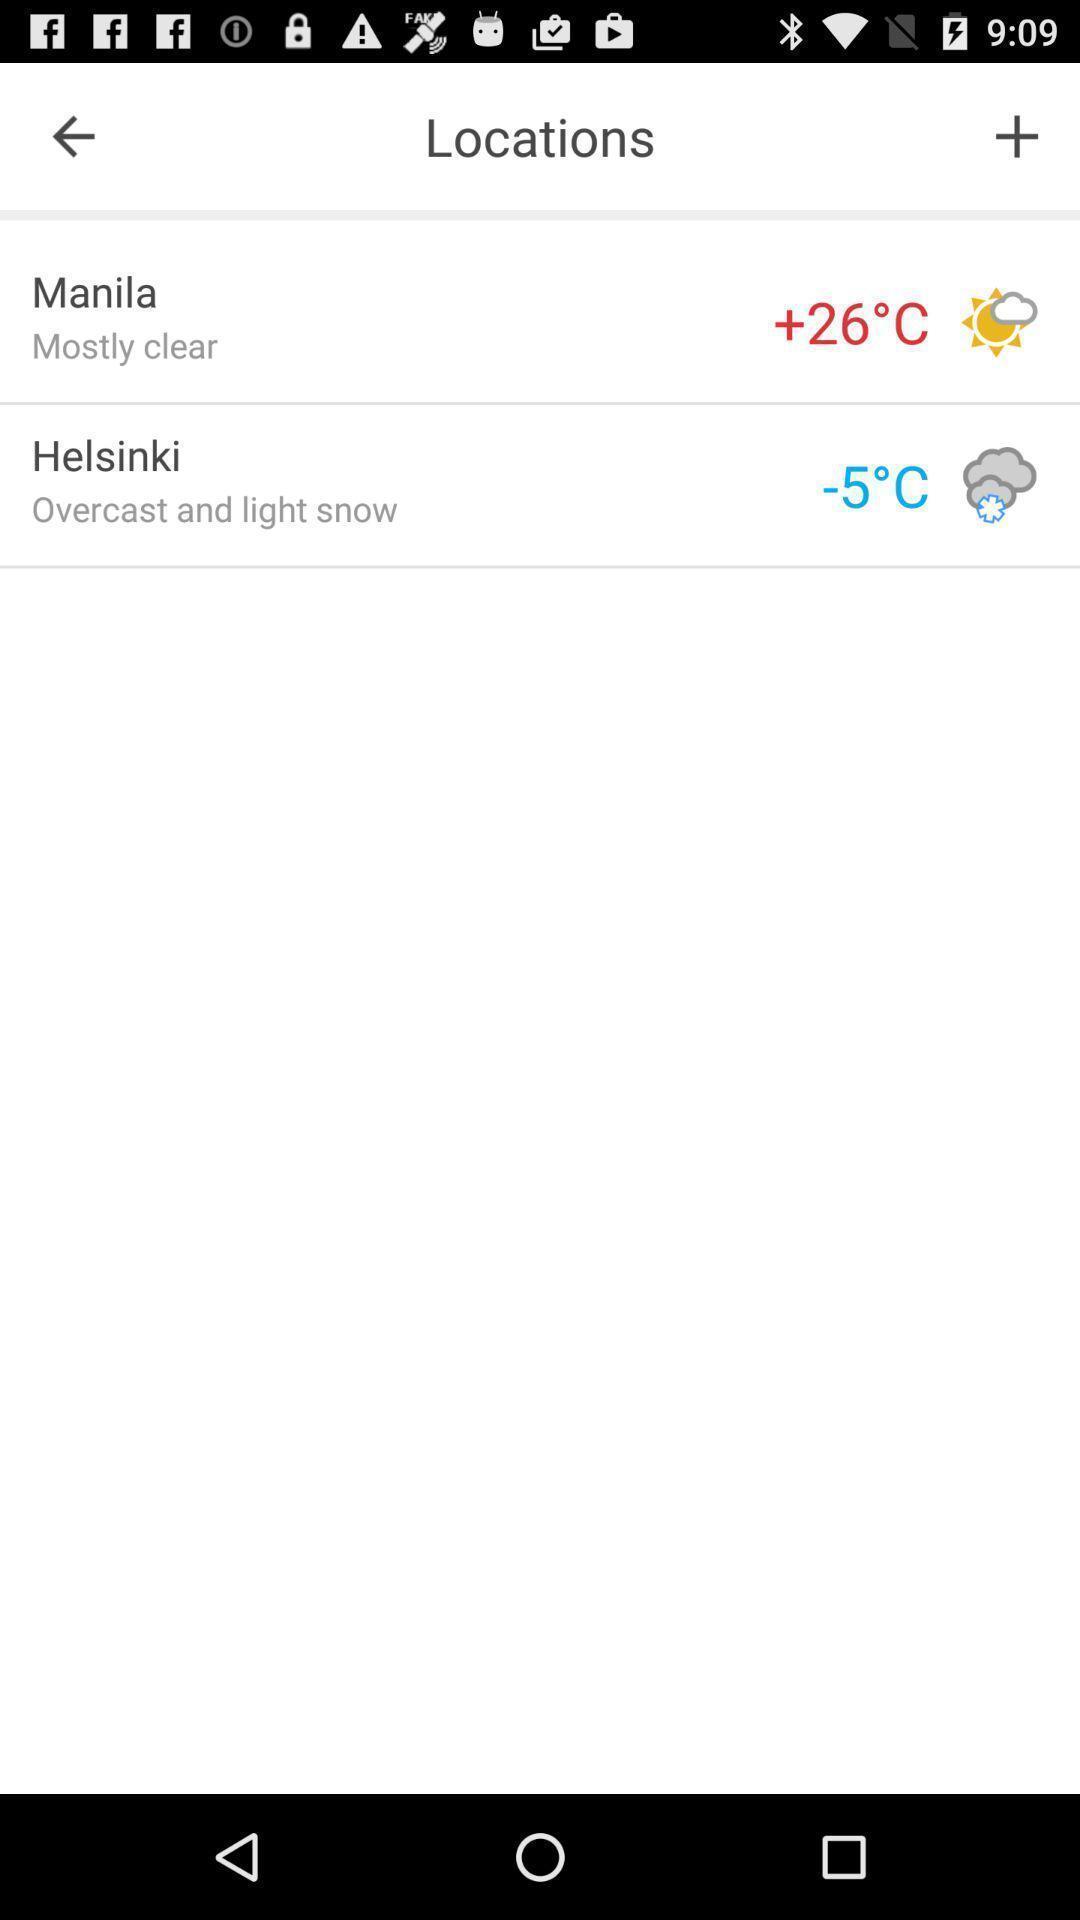Provide a description of this screenshot. Weather details of a location. 